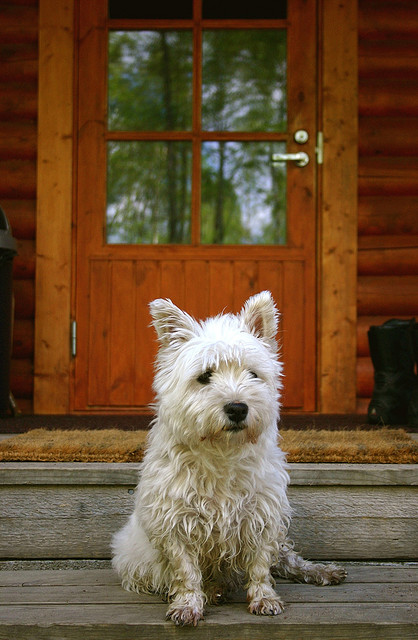How would you describe the temperament of this dog breed? West Highland White Terriers, or Westies, generally have a friendly and jolly disposition. They're known for being spirited and self-reliant, making them excellent companions. However, they can show a bit of a stubborn streak and require consistent, positive training from an early age. 